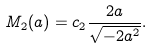<formula> <loc_0><loc_0><loc_500><loc_500>M _ { 2 } ( a ) = c _ { 2 } \frac { 2 a } { \sqrt { - 2 a ^ { 2 } } } .</formula> 